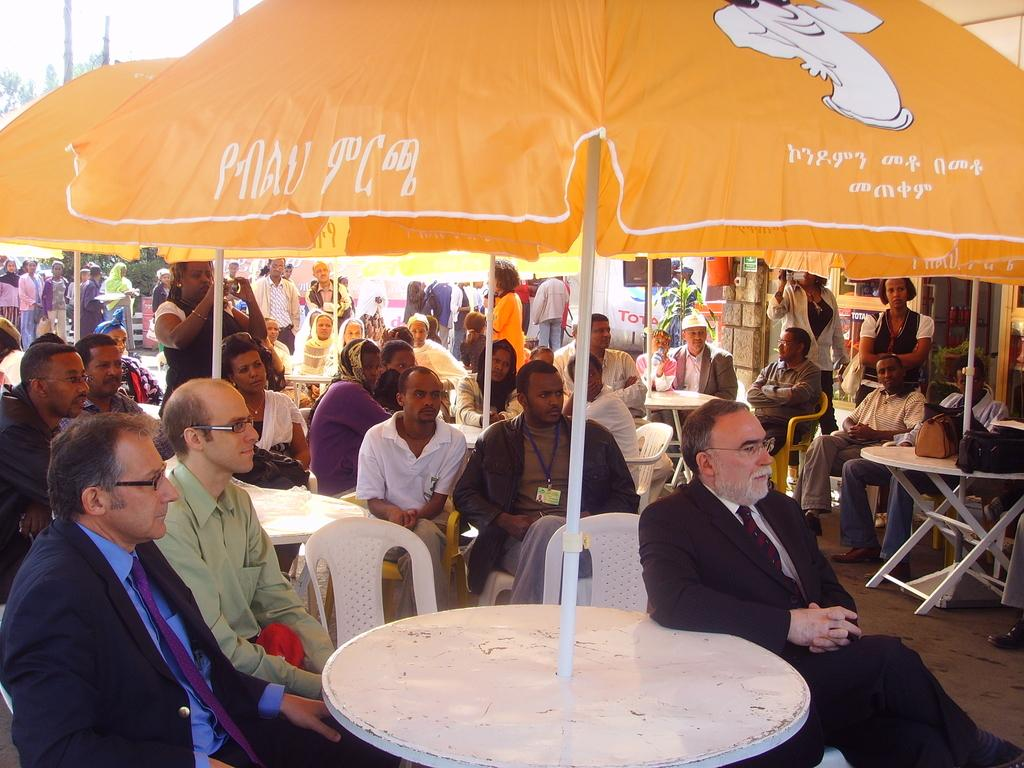How many people are in the image? There is a group of persons in the image. What are the persons in the image doing? The group of persons is sitting. What color is the umbrella in the image? There is a yellow color umbrella in the image. Where are the persons in the image located? The group of persons is under the yellow color umbrella. What type of bun is being served to the boys in the image? There is no mention of buns or boys in the image. The image features a group of persons sitting under a yellow umbrella. What type of industry is depicted in the image? The image does not depict any industry; it shows a group of persons sitting under a yellow umbrella. 